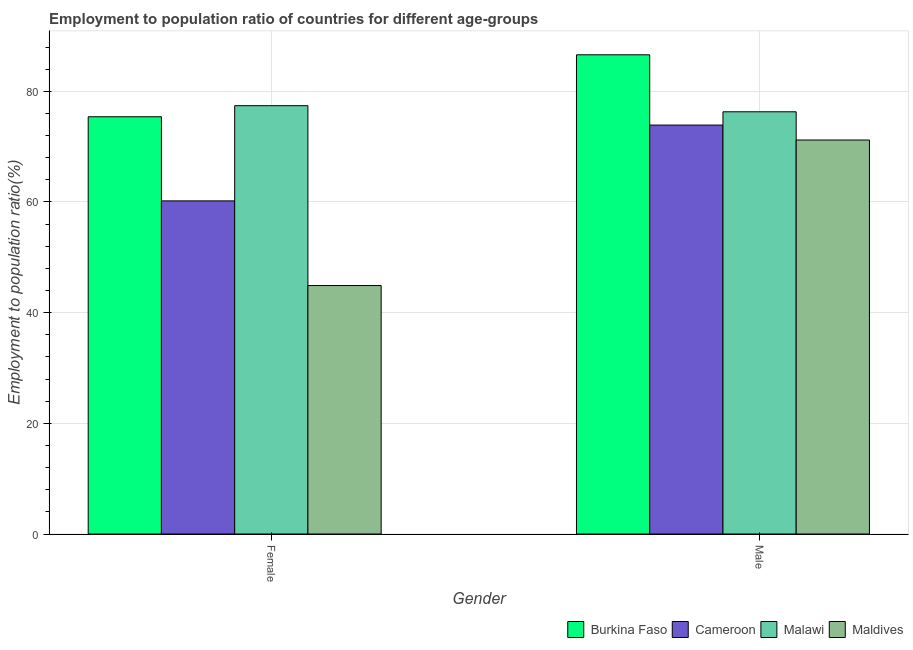How many different coloured bars are there?
Ensure brevity in your answer.  4. How many groups of bars are there?
Keep it short and to the point. 2. Are the number of bars per tick equal to the number of legend labels?
Provide a short and direct response. Yes. Are the number of bars on each tick of the X-axis equal?
Give a very brief answer. Yes. What is the employment to population ratio(female) in Cameroon?
Keep it short and to the point. 60.2. Across all countries, what is the maximum employment to population ratio(male)?
Make the answer very short. 86.6. Across all countries, what is the minimum employment to population ratio(female)?
Your answer should be very brief. 44.9. In which country was the employment to population ratio(female) maximum?
Offer a very short reply. Malawi. In which country was the employment to population ratio(female) minimum?
Offer a terse response. Maldives. What is the total employment to population ratio(female) in the graph?
Your response must be concise. 257.9. What is the difference between the employment to population ratio(male) in Burkina Faso and that in Maldives?
Offer a very short reply. 15.4. What is the difference between the employment to population ratio(female) in Burkina Faso and the employment to population ratio(male) in Malawi?
Ensure brevity in your answer.  -0.9. What is the average employment to population ratio(male) per country?
Give a very brief answer. 77. What is the difference between the employment to population ratio(male) and employment to population ratio(female) in Maldives?
Your answer should be compact. 26.3. In how many countries, is the employment to population ratio(female) greater than 36 %?
Provide a short and direct response. 4. What is the ratio of the employment to population ratio(male) in Maldives to that in Burkina Faso?
Your answer should be compact. 0.82. Is the employment to population ratio(female) in Cameroon less than that in Malawi?
Provide a succinct answer. Yes. In how many countries, is the employment to population ratio(male) greater than the average employment to population ratio(male) taken over all countries?
Your response must be concise. 1. What does the 1st bar from the left in Male represents?
Provide a succinct answer. Burkina Faso. What does the 2nd bar from the right in Female represents?
Keep it short and to the point. Malawi. How many bars are there?
Make the answer very short. 8. Are the values on the major ticks of Y-axis written in scientific E-notation?
Provide a succinct answer. No. Where does the legend appear in the graph?
Make the answer very short. Bottom right. How are the legend labels stacked?
Provide a short and direct response. Horizontal. What is the title of the graph?
Make the answer very short. Employment to population ratio of countries for different age-groups. What is the label or title of the X-axis?
Provide a succinct answer. Gender. What is the label or title of the Y-axis?
Ensure brevity in your answer.  Employment to population ratio(%). What is the Employment to population ratio(%) of Burkina Faso in Female?
Offer a terse response. 75.4. What is the Employment to population ratio(%) of Cameroon in Female?
Offer a very short reply. 60.2. What is the Employment to population ratio(%) of Malawi in Female?
Offer a very short reply. 77.4. What is the Employment to population ratio(%) of Maldives in Female?
Keep it short and to the point. 44.9. What is the Employment to population ratio(%) in Burkina Faso in Male?
Offer a terse response. 86.6. What is the Employment to population ratio(%) of Cameroon in Male?
Make the answer very short. 73.9. What is the Employment to population ratio(%) of Malawi in Male?
Your answer should be compact. 76.3. What is the Employment to population ratio(%) in Maldives in Male?
Provide a short and direct response. 71.2. Across all Gender, what is the maximum Employment to population ratio(%) of Burkina Faso?
Provide a short and direct response. 86.6. Across all Gender, what is the maximum Employment to population ratio(%) of Cameroon?
Give a very brief answer. 73.9. Across all Gender, what is the maximum Employment to population ratio(%) in Malawi?
Give a very brief answer. 77.4. Across all Gender, what is the maximum Employment to population ratio(%) in Maldives?
Provide a succinct answer. 71.2. Across all Gender, what is the minimum Employment to population ratio(%) of Burkina Faso?
Give a very brief answer. 75.4. Across all Gender, what is the minimum Employment to population ratio(%) in Cameroon?
Provide a short and direct response. 60.2. Across all Gender, what is the minimum Employment to population ratio(%) of Malawi?
Ensure brevity in your answer.  76.3. Across all Gender, what is the minimum Employment to population ratio(%) in Maldives?
Give a very brief answer. 44.9. What is the total Employment to population ratio(%) in Burkina Faso in the graph?
Give a very brief answer. 162. What is the total Employment to population ratio(%) in Cameroon in the graph?
Offer a terse response. 134.1. What is the total Employment to population ratio(%) of Malawi in the graph?
Offer a very short reply. 153.7. What is the total Employment to population ratio(%) of Maldives in the graph?
Give a very brief answer. 116.1. What is the difference between the Employment to population ratio(%) of Burkina Faso in Female and that in Male?
Your response must be concise. -11.2. What is the difference between the Employment to population ratio(%) of Cameroon in Female and that in Male?
Make the answer very short. -13.7. What is the difference between the Employment to population ratio(%) of Malawi in Female and that in Male?
Ensure brevity in your answer.  1.1. What is the difference between the Employment to population ratio(%) in Maldives in Female and that in Male?
Give a very brief answer. -26.3. What is the difference between the Employment to population ratio(%) of Cameroon in Female and the Employment to population ratio(%) of Malawi in Male?
Keep it short and to the point. -16.1. What is the difference between the Employment to population ratio(%) of Cameroon in Female and the Employment to population ratio(%) of Maldives in Male?
Your answer should be very brief. -11. What is the average Employment to population ratio(%) of Cameroon per Gender?
Your response must be concise. 67.05. What is the average Employment to population ratio(%) in Malawi per Gender?
Ensure brevity in your answer.  76.85. What is the average Employment to population ratio(%) in Maldives per Gender?
Your answer should be compact. 58.05. What is the difference between the Employment to population ratio(%) of Burkina Faso and Employment to population ratio(%) of Cameroon in Female?
Your response must be concise. 15.2. What is the difference between the Employment to population ratio(%) in Burkina Faso and Employment to population ratio(%) in Malawi in Female?
Give a very brief answer. -2. What is the difference between the Employment to population ratio(%) of Burkina Faso and Employment to population ratio(%) of Maldives in Female?
Make the answer very short. 30.5. What is the difference between the Employment to population ratio(%) in Cameroon and Employment to population ratio(%) in Malawi in Female?
Your answer should be compact. -17.2. What is the difference between the Employment to population ratio(%) of Malawi and Employment to population ratio(%) of Maldives in Female?
Provide a short and direct response. 32.5. What is the difference between the Employment to population ratio(%) of Burkina Faso and Employment to population ratio(%) of Cameroon in Male?
Give a very brief answer. 12.7. What is the difference between the Employment to population ratio(%) in Cameroon and Employment to population ratio(%) in Maldives in Male?
Give a very brief answer. 2.7. What is the difference between the Employment to population ratio(%) in Malawi and Employment to population ratio(%) in Maldives in Male?
Provide a succinct answer. 5.1. What is the ratio of the Employment to population ratio(%) of Burkina Faso in Female to that in Male?
Ensure brevity in your answer.  0.87. What is the ratio of the Employment to population ratio(%) in Cameroon in Female to that in Male?
Provide a succinct answer. 0.81. What is the ratio of the Employment to population ratio(%) of Malawi in Female to that in Male?
Keep it short and to the point. 1.01. What is the ratio of the Employment to population ratio(%) in Maldives in Female to that in Male?
Make the answer very short. 0.63. What is the difference between the highest and the second highest Employment to population ratio(%) in Burkina Faso?
Your answer should be very brief. 11.2. What is the difference between the highest and the second highest Employment to population ratio(%) in Cameroon?
Offer a very short reply. 13.7. What is the difference between the highest and the second highest Employment to population ratio(%) in Maldives?
Offer a terse response. 26.3. What is the difference between the highest and the lowest Employment to population ratio(%) in Burkina Faso?
Make the answer very short. 11.2. What is the difference between the highest and the lowest Employment to population ratio(%) of Cameroon?
Give a very brief answer. 13.7. What is the difference between the highest and the lowest Employment to population ratio(%) in Malawi?
Make the answer very short. 1.1. What is the difference between the highest and the lowest Employment to population ratio(%) in Maldives?
Give a very brief answer. 26.3. 